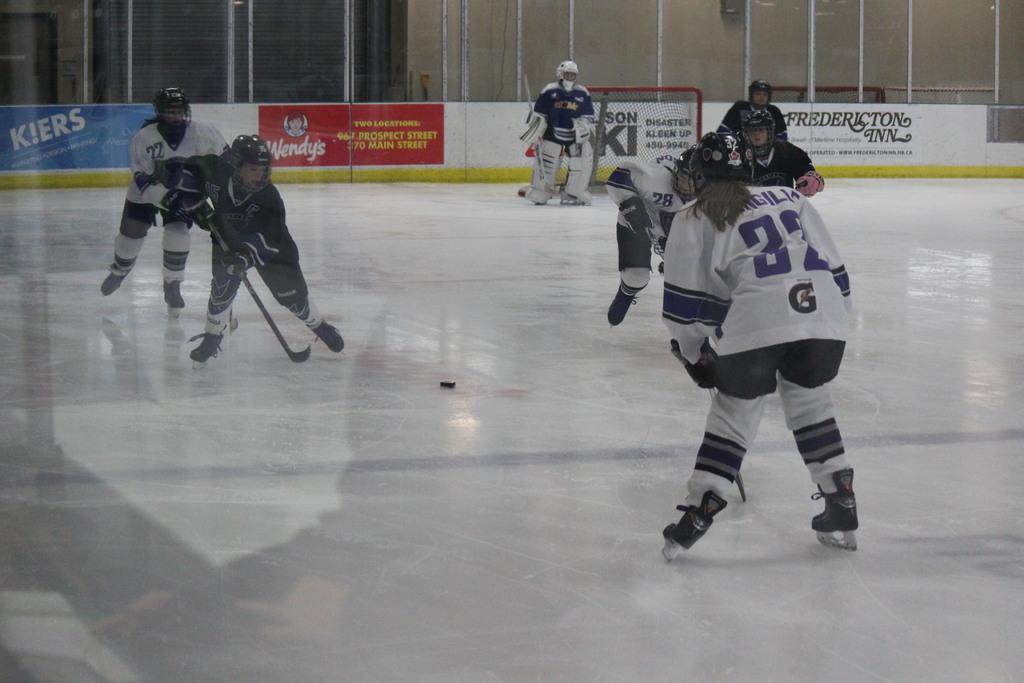How would you summarize this image in a sentence or two? In this image we can see group of lady persons wearing sports dress, helmets playing ice hockey and in the background of the image there is fencing, board. 